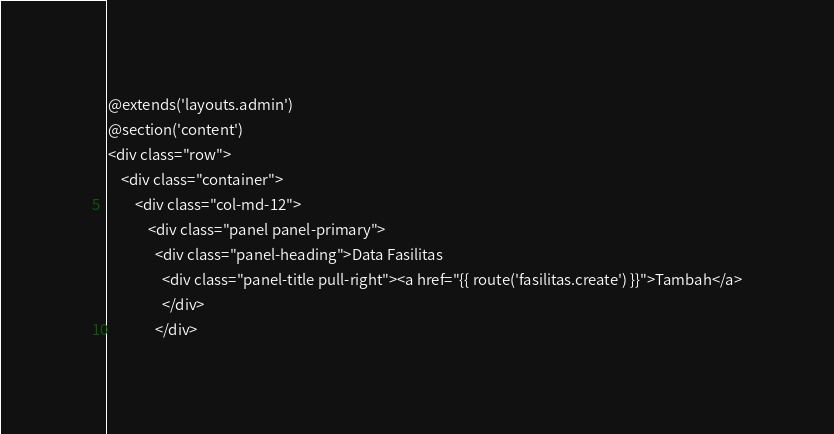<code> <loc_0><loc_0><loc_500><loc_500><_PHP_>@extends('layouts.admin')
@section('content')
<div class="row">
	<div class="container">
		<div class="col-md-12">
			<div class="panel panel-primary">
			  <div class="panel-heading">Data Fasilitas
			  	<div class="panel-title pull-right"><a href="{{ route('fasilitas.create') }}">Tambah</a>
			  	</div>
			  </div></code> 